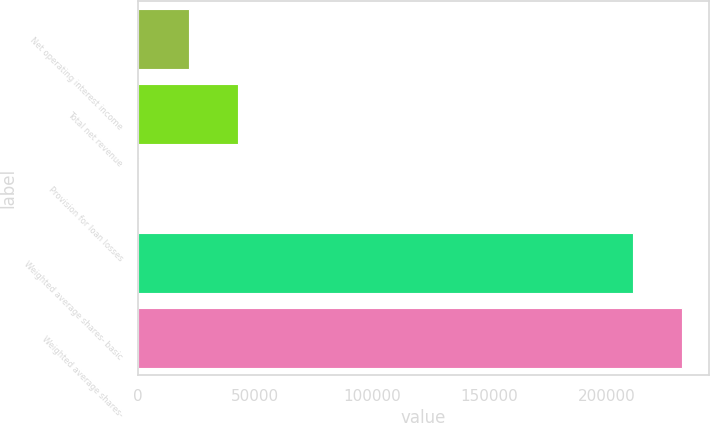<chart> <loc_0><loc_0><loc_500><loc_500><bar_chart><fcel>Net operating interest income<fcel>Total net revenue<fcel>Provision for loan losses<fcel>Weighted average shares- basic<fcel>Weighted average shares-<nl><fcel>21831.7<fcel>42883.9<fcel>779.4<fcel>211302<fcel>232354<nl></chart> 